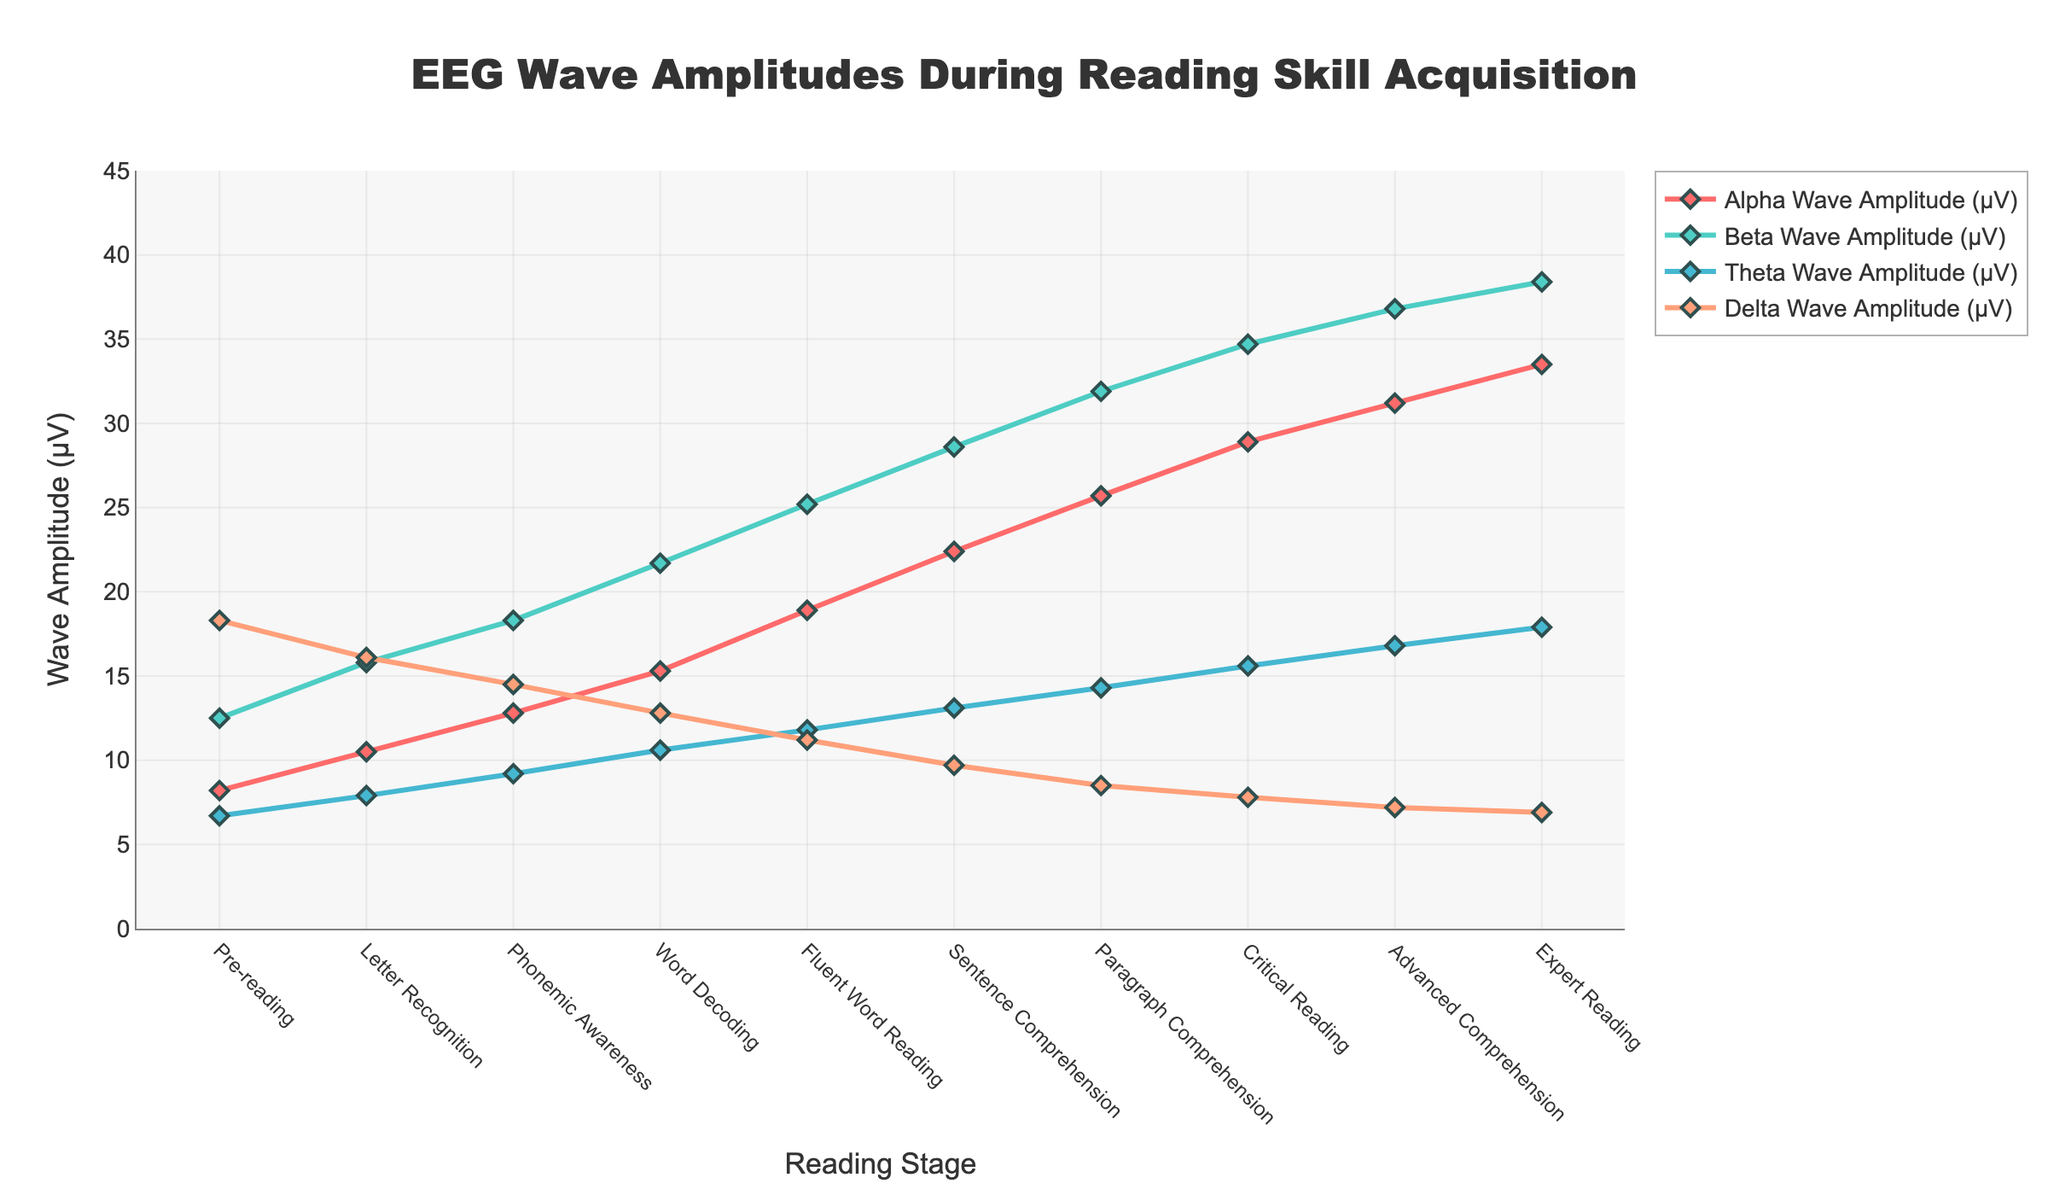What's the reading stage with the highest alpha wave amplitude? Locate the 'Alpha Wave Amplitude (μV)' line and find the highest point on the y-axis across all reading stages. This point corresponds to the 'Expert Reading' stage.
Answer: Expert Reading Which wave has the steepest increase from 'Pre-reading' to 'Expert Reading'? Compare the slopes of all four lines from 'Pre-reading' to 'Expert Reading'. The 'Alpha Wave Amplitude (μV)' line shows the steepest increase, going from 8.2 to 33.5.
Answer: Alpha Wave How does the beta wave amplitude change from 'Phonemic Awareness' to 'Fluent Word Reading'? Find the 'Beta Wave Amplitude (μV)' values at 'Phonemic Awareness' and 'Fluent Word Reading'. The values are 18.3 and 25.2, respectively, indicating an increase.
Answer: It increases What is the sum of delta wave amplitudes at 'Fluent Word Reading' and 'Sentence Comprehension'? Add the 'Delta Wave Amplitude (μV)' values at 'Fluent Word Reading' (11.2) and 'Sentence Comprehension' (9.7). 11.2 + 9.7 = 20.9
Answer: 20.9 Do theta wave amplitudes consistently increase or decrease across reading stages? Follow the 'Theta Wave Amplitude (μV)' line from 'Pre-reading' to 'Expert Reading'. The values consistently increase from 6.7 to 17.9, indicating a steady upward trend.
Answer: Increase Which has a higher amplitude at 'Paragraph Comprehension', alpha or beta waves? Compare the 'Alpha Wave Amplitude (μV)' (25.7) and 'Beta Wave Amplitude (μV)' (31.9) at 'Paragraph Comprehension'. The beta wave has a higher amplitude.
Answer: Beta waves How does delta wave amplitude at 'Letter Recognition' compare to 'Critical Reading'? Look at the 'Delta Wave Amplitude (μV)' values for 'Letter Recognition' (16.1) and 'Critical Reading' (7.8). The amplitude decreases from 'Letter Recognition' to 'Critical Reading'.
Answer: It decreases What is the average theta wave amplitude across all reading stages? Add all the theta wave amplitude values and divide by the number of stages: (6.7 + 7.9 + 9.2 + 10.6 + 11.8 + 13.1 + 14.3 + 15.6 + 16.8 + 17.9)/10 = 12.39
Answer: 12.39 Is there any reading stage where delta waves have the lowest amplitude among all wave types? Compare the four wave amplitudes at each reading stage. At 'Fluent Word Reading', 'Sentence Comprehension', 'Paragraph Comprehension', 'Critical Reading', and 'Advanced Comprehension', delta waves have the lowest amplitude.
Answer: Yes What is the difference in alpha wave amplitude between 'Pre-reading' and 'Expert Reading'? Subtract the 'Alpha Wave Amplitude (μV)' at 'Pre-reading' (8.2) from that at 'Expert Reading' (33.5). 33.5 - 8.2 = 25.3
Answer: 25.3 